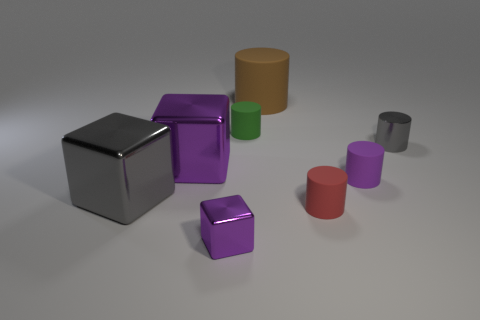Add 2 small green rubber objects. How many objects exist? 10 Subtract all small green rubber cylinders. How many cylinders are left? 4 Subtract all cubes. How many objects are left? 5 Subtract 4 cylinders. How many cylinders are left? 1 Subtract all red cubes. Subtract all green balls. How many cubes are left? 3 Subtract all blue cylinders. How many purple cubes are left? 2 Subtract all purple objects. Subtract all small purple blocks. How many objects are left? 4 Add 1 small green objects. How many small green objects are left? 2 Add 6 small rubber objects. How many small rubber objects exist? 9 Subtract all purple blocks. How many blocks are left? 1 